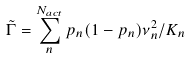<formula> <loc_0><loc_0><loc_500><loc_500>\tilde { \Gamma } = \sum _ { n } ^ { N _ { a c t } } p _ { n } ( 1 - p _ { n } ) \nu _ { n } ^ { 2 } / K _ { n }</formula> 